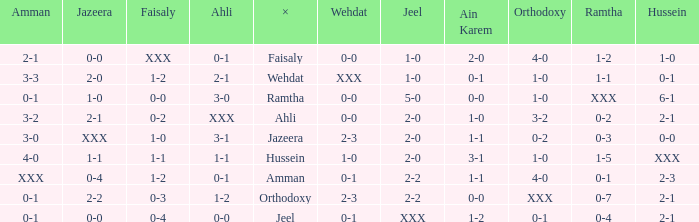What is ahli when ramtha is 0-4? 0-0. 